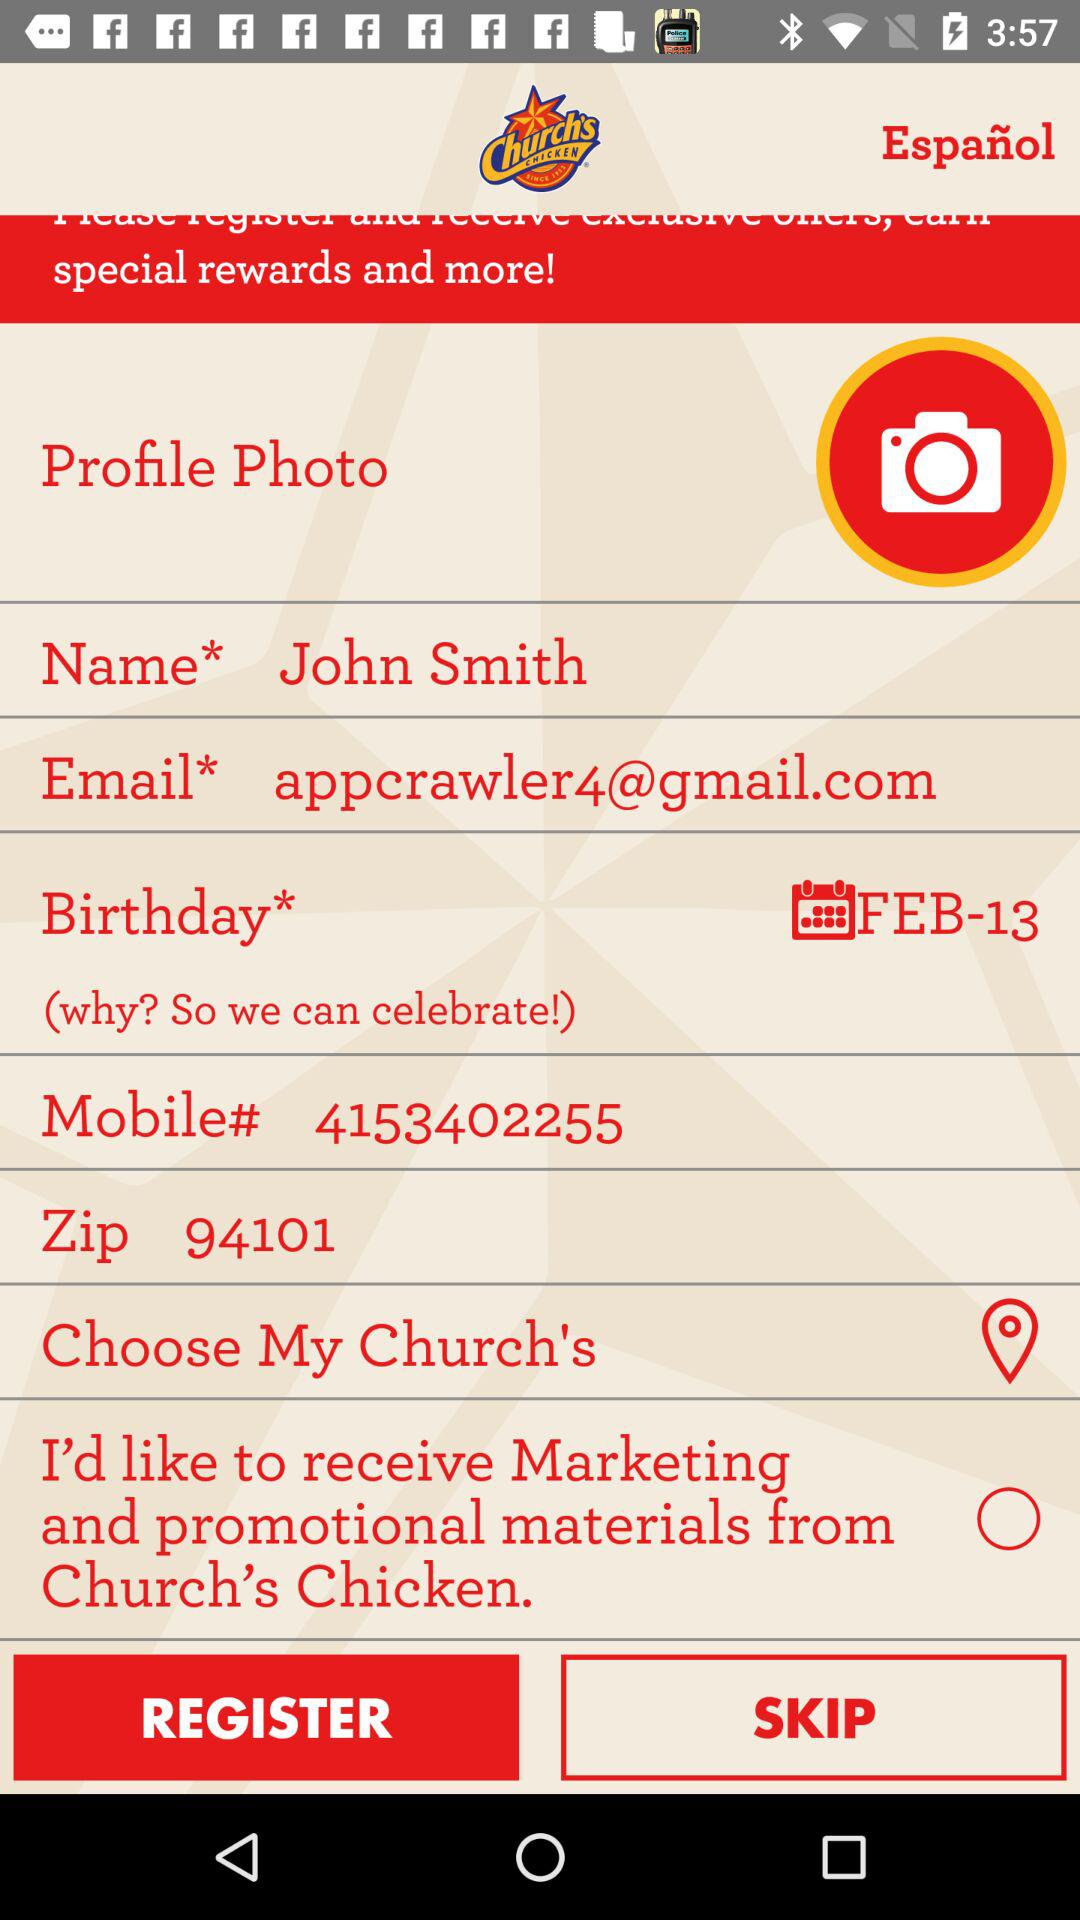How far away is the chosen Church's Chicken location?
When the provided information is insufficient, respond with <no answer>. <no answer> 